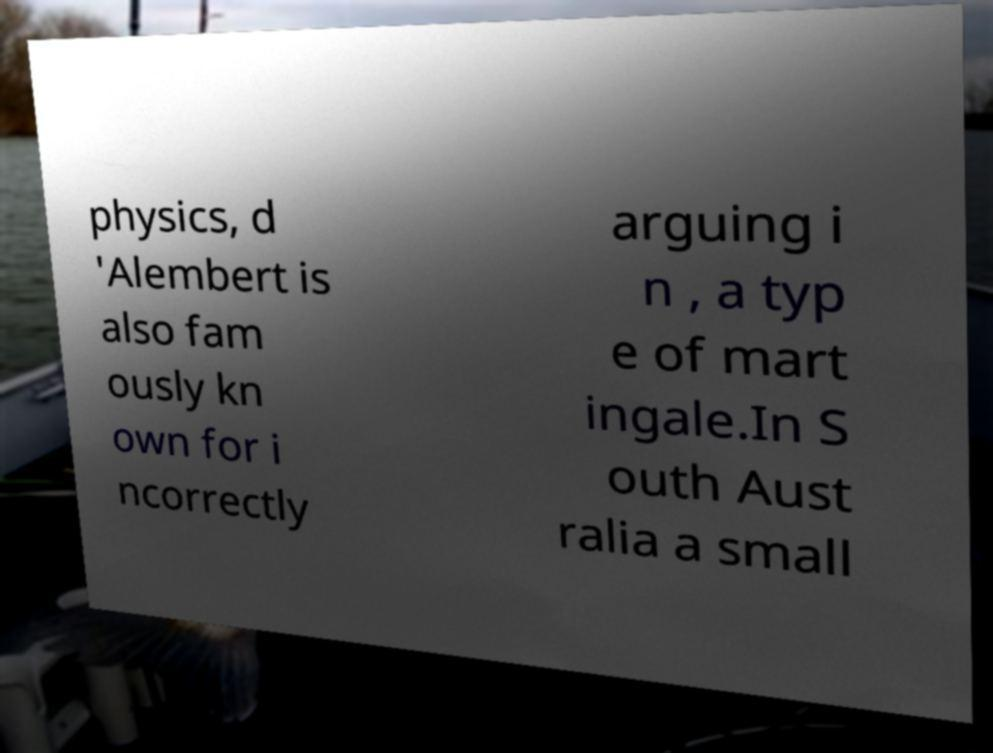Please identify and transcribe the text found in this image. physics, d 'Alembert is also fam ously kn own for i ncorrectly arguing i n , a typ e of mart ingale.In S outh Aust ralia a small 